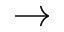Convert formula to latex. <formula><loc_0><loc_0><loc_500><loc_500>\to</formula> 